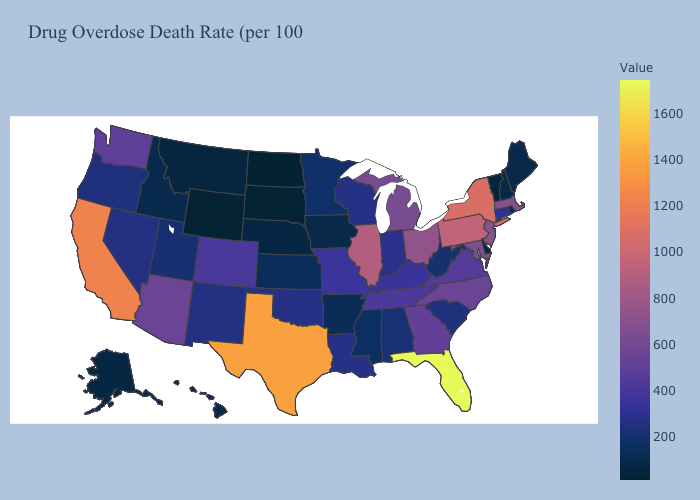Among the states that border New Jersey , does Delaware have the highest value?
Quick response, please. No. Among the states that border Oklahoma , which have the highest value?
Short answer required. Texas. Which states have the highest value in the USA?
Give a very brief answer. Florida. Does Massachusetts have the lowest value in the USA?
Short answer required. No. Does Vermont have the lowest value in the Northeast?
Answer briefly. Yes. Among the states that border Missouri , which have the lowest value?
Quick response, please. Nebraska. Does Arkansas have the lowest value in the USA?
Keep it brief. No. Which states have the lowest value in the USA?
Short answer required. North Dakota. Is the legend a continuous bar?
Write a very short answer. Yes. 